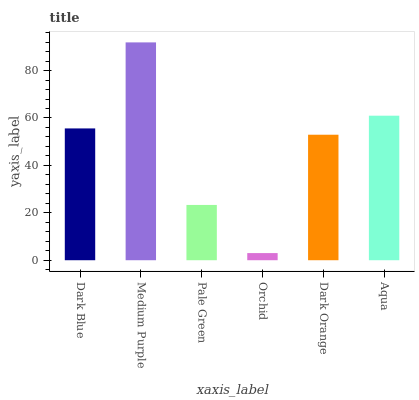Is Orchid the minimum?
Answer yes or no. Yes. Is Medium Purple the maximum?
Answer yes or no. Yes. Is Pale Green the minimum?
Answer yes or no. No. Is Pale Green the maximum?
Answer yes or no. No. Is Medium Purple greater than Pale Green?
Answer yes or no. Yes. Is Pale Green less than Medium Purple?
Answer yes or no. Yes. Is Pale Green greater than Medium Purple?
Answer yes or no. No. Is Medium Purple less than Pale Green?
Answer yes or no. No. Is Dark Blue the high median?
Answer yes or no. Yes. Is Dark Orange the low median?
Answer yes or no. Yes. Is Dark Orange the high median?
Answer yes or no. No. Is Orchid the low median?
Answer yes or no. No. 